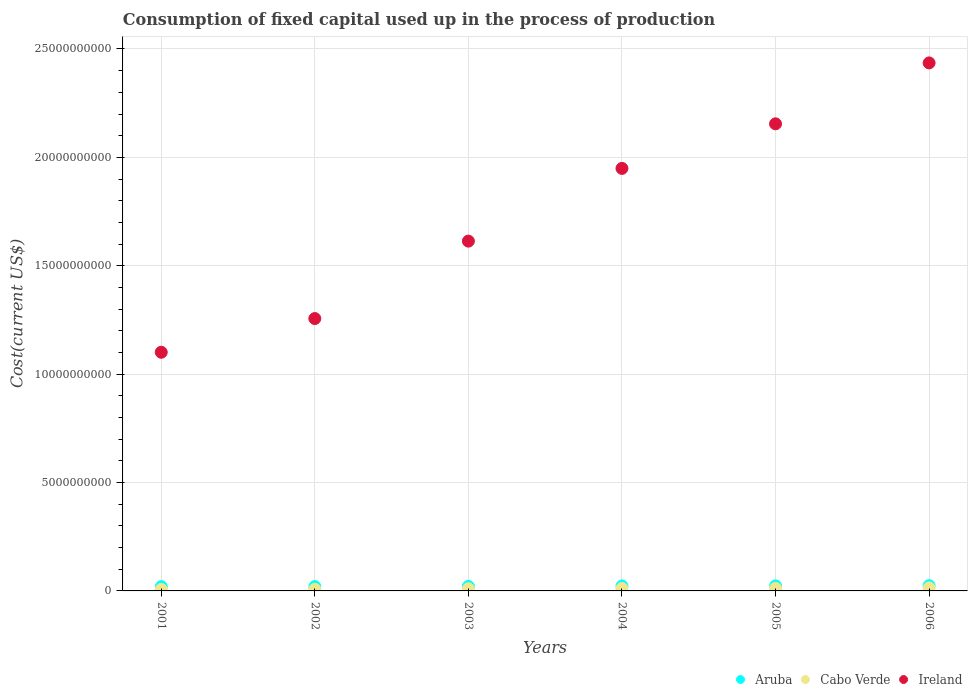What is the amount consumed in the process of production in Cabo Verde in 2005?
Your response must be concise. 1.20e+08. Across all years, what is the maximum amount consumed in the process of production in Cabo Verde?
Your answer should be very brief. 1.40e+08. Across all years, what is the minimum amount consumed in the process of production in Cabo Verde?
Give a very brief answer. 6.93e+07. In which year was the amount consumed in the process of production in Cabo Verde maximum?
Your response must be concise. 2006. What is the total amount consumed in the process of production in Cabo Verde in the graph?
Provide a succinct answer. 6.21e+08. What is the difference between the amount consumed in the process of production in Ireland in 2001 and that in 2006?
Ensure brevity in your answer.  -1.33e+1. What is the difference between the amount consumed in the process of production in Cabo Verde in 2004 and the amount consumed in the process of production in Aruba in 2003?
Your response must be concise. -9.54e+07. What is the average amount consumed in the process of production in Ireland per year?
Offer a very short reply. 1.75e+1. In the year 2002, what is the difference between the amount consumed in the process of production in Aruba and amount consumed in the process of production in Ireland?
Ensure brevity in your answer.  -1.24e+1. In how many years, is the amount consumed in the process of production in Cabo Verde greater than 17000000000 US$?
Ensure brevity in your answer.  0. What is the ratio of the amount consumed in the process of production in Cabo Verde in 2001 to that in 2002?
Your answer should be very brief. 0.9. Is the difference between the amount consumed in the process of production in Aruba in 2002 and 2005 greater than the difference between the amount consumed in the process of production in Ireland in 2002 and 2005?
Provide a short and direct response. Yes. What is the difference between the highest and the second highest amount consumed in the process of production in Ireland?
Give a very brief answer. 2.81e+09. What is the difference between the highest and the lowest amount consumed in the process of production in Aruba?
Provide a succinct answer. 4.61e+07. Is the sum of the amount consumed in the process of production in Cabo Verde in 2005 and 2006 greater than the maximum amount consumed in the process of production in Ireland across all years?
Make the answer very short. No. Is it the case that in every year, the sum of the amount consumed in the process of production in Cabo Verde and amount consumed in the process of production in Aruba  is greater than the amount consumed in the process of production in Ireland?
Your response must be concise. No. Does the amount consumed in the process of production in Cabo Verde monotonically increase over the years?
Provide a short and direct response. Yes. Is the amount consumed in the process of production in Ireland strictly less than the amount consumed in the process of production in Aruba over the years?
Your response must be concise. No. What is the difference between two consecutive major ticks on the Y-axis?
Ensure brevity in your answer.  5.00e+09. Are the values on the major ticks of Y-axis written in scientific E-notation?
Provide a short and direct response. No. Does the graph contain any zero values?
Provide a short and direct response. No. Does the graph contain grids?
Give a very brief answer. Yes. How many legend labels are there?
Give a very brief answer. 3. How are the legend labels stacked?
Keep it short and to the point. Horizontal. What is the title of the graph?
Your answer should be very brief. Consumption of fixed capital used up in the process of production. What is the label or title of the Y-axis?
Provide a succinct answer. Cost(current US$). What is the Cost(current US$) of Aruba in 2001?
Your answer should be compact. 1.98e+08. What is the Cost(current US$) of Cabo Verde in 2001?
Offer a terse response. 6.93e+07. What is the Cost(current US$) of Ireland in 2001?
Give a very brief answer. 1.10e+1. What is the Cost(current US$) in Aruba in 2002?
Make the answer very short. 2.00e+08. What is the Cost(current US$) of Cabo Verde in 2002?
Offer a very short reply. 7.71e+07. What is the Cost(current US$) in Ireland in 2002?
Give a very brief answer. 1.26e+1. What is the Cost(current US$) in Aruba in 2003?
Ensure brevity in your answer.  2.09e+08. What is the Cost(current US$) in Cabo Verde in 2003?
Offer a very short reply. 1.00e+08. What is the Cost(current US$) in Ireland in 2003?
Your answer should be compact. 1.61e+1. What is the Cost(current US$) of Aruba in 2004?
Your answer should be compact. 2.29e+08. What is the Cost(current US$) in Cabo Verde in 2004?
Offer a terse response. 1.13e+08. What is the Cost(current US$) of Ireland in 2004?
Ensure brevity in your answer.  1.95e+1. What is the Cost(current US$) in Aruba in 2005?
Provide a succinct answer. 2.33e+08. What is the Cost(current US$) of Cabo Verde in 2005?
Make the answer very short. 1.20e+08. What is the Cost(current US$) in Ireland in 2005?
Give a very brief answer. 2.15e+1. What is the Cost(current US$) in Aruba in 2006?
Make the answer very short. 2.44e+08. What is the Cost(current US$) of Cabo Verde in 2006?
Offer a very short reply. 1.40e+08. What is the Cost(current US$) of Ireland in 2006?
Offer a terse response. 2.44e+1. Across all years, what is the maximum Cost(current US$) of Aruba?
Offer a very short reply. 2.44e+08. Across all years, what is the maximum Cost(current US$) in Cabo Verde?
Give a very brief answer. 1.40e+08. Across all years, what is the maximum Cost(current US$) of Ireland?
Offer a terse response. 2.44e+1. Across all years, what is the minimum Cost(current US$) of Aruba?
Your answer should be compact. 1.98e+08. Across all years, what is the minimum Cost(current US$) of Cabo Verde?
Your answer should be compact. 6.93e+07. Across all years, what is the minimum Cost(current US$) in Ireland?
Provide a succinct answer. 1.10e+1. What is the total Cost(current US$) of Aruba in the graph?
Your response must be concise. 1.31e+09. What is the total Cost(current US$) in Cabo Verde in the graph?
Your answer should be very brief. 6.21e+08. What is the total Cost(current US$) of Ireland in the graph?
Give a very brief answer. 1.05e+11. What is the difference between the Cost(current US$) in Aruba in 2001 and that in 2002?
Your answer should be very brief. -2.55e+06. What is the difference between the Cost(current US$) of Cabo Verde in 2001 and that in 2002?
Give a very brief answer. -7.80e+06. What is the difference between the Cost(current US$) of Ireland in 2001 and that in 2002?
Your answer should be compact. -1.55e+09. What is the difference between the Cost(current US$) of Aruba in 2001 and that in 2003?
Offer a terse response. -1.09e+07. What is the difference between the Cost(current US$) in Cabo Verde in 2001 and that in 2003?
Your response must be concise. -3.11e+07. What is the difference between the Cost(current US$) of Ireland in 2001 and that in 2003?
Your answer should be very brief. -5.13e+09. What is the difference between the Cost(current US$) in Aruba in 2001 and that in 2004?
Offer a very short reply. -3.11e+07. What is the difference between the Cost(current US$) of Cabo Verde in 2001 and that in 2004?
Provide a short and direct response. -4.38e+07. What is the difference between the Cost(current US$) of Ireland in 2001 and that in 2004?
Your response must be concise. -8.48e+09. What is the difference between the Cost(current US$) of Aruba in 2001 and that in 2005?
Keep it short and to the point. -3.52e+07. What is the difference between the Cost(current US$) of Cabo Verde in 2001 and that in 2005?
Make the answer very short. -5.11e+07. What is the difference between the Cost(current US$) in Ireland in 2001 and that in 2005?
Offer a terse response. -1.05e+1. What is the difference between the Cost(current US$) of Aruba in 2001 and that in 2006?
Keep it short and to the point. -4.61e+07. What is the difference between the Cost(current US$) in Cabo Verde in 2001 and that in 2006?
Provide a short and direct response. -7.11e+07. What is the difference between the Cost(current US$) in Ireland in 2001 and that in 2006?
Keep it short and to the point. -1.33e+1. What is the difference between the Cost(current US$) in Aruba in 2002 and that in 2003?
Your answer should be very brief. -8.33e+06. What is the difference between the Cost(current US$) in Cabo Verde in 2002 and that in 2003?
Your response must be concise. -2.33e+07. What is the difference between the Cost(current US$) of Ireland in 2002 and that in 2003?
Your answer should be compact. -3.57e+09. What is the difference between the Cost(current US$) in Aruba in 2002 and that in 2004?
Keep it short and to the point. -2.85e+07. What is the difference between the Cost(current US$) of Cabo Verde in 2002 and that in 2004?
Provide a succinct answer. -3.60e+07. What is the difference between the Cost(current US$) in Ireland in 2002 and that in 2004?
Your answer should be very brief. -6.93e+09. What is the difference between the Cost(current US$) in Aruba in 2002 and that in 2005?
Offer a terse response. -3.26e+07. What is the difference between the Cost(current US$) of Cabo Verde in 2002 and that in 2005?
Offer a very short reply. -4.33e+07. What is the difference between the Cost(current US$) in Ireland in 2002 and that in 2005?
Provide a short and direct response. -8.98e+09. What is the difference between the Cost(current US$) of Aruba in 2002 and that in 2006?
Offer a very short reply. -4.35e+07. What is the difference between the Cost(current US$) in Cabo Verde in 2002 and that in 2006?
Ensure brevity in your answer.  -6.33e+07. What is the difference between the Cost(current US$) of Ireland in 2002 and that in 2006?
Your answer should be very brief. -1.18e+1. What is the difference between the Cost(current US$) of Aruba in 2003 and that in 2004?
Your response must be concise. -2.02e+07. What is the difference between the Cost(current US$) in Cabo Verde in 2003 and that in 2004?
Provide a succinct answer. -1.27e+07. What is the difference between the Cost(current US$) of Ireland in 2003 and that in 2004?
Your answer should be very brief. -3.36e+09. What is the difference between the Cost(current US$) of Aruba in 2003 and that in 2005?
Your answer should be very brief. -2.43e+07. What is the difference between the Cost(current US$) in Cabo Verde in 2003 and that in 2005?
Your answer should be very brief. -2.00e+07. What is the difference between the Cost(current US$) of Ireland in 2003 and that in 2005?
Offer a terse response. -5.41e+09. What is the difference between the Cost(current US$) in Aruba in 2003 and that in 2006?
Your response must be concise. -3.52e+07. What is the difference between the Cost(current US$) of Cabo Verde in 2003 and that in 2006?
Your response must be concise. -4.00e+07. What is the difference between the Cost(current US$) in Ireland in 2003 and that in 2006?
Offer a very short reply. -8.22e+09. What is the difference between the Cost(current US$) of Aruba in 2004 and that in 2005?
Offer a very short reply. -4.15e+06. What is the difference between the Cost(current US$) in Cabo Verde in 2004 and that in 2005?
Provide a succinct answer. -7.27e+06. What is the difference between the Cost(current US$) in Ireland in 2004 and that in 2005?
Your answer should be very brief. -2.06e+09. What is the difference between the Cost(current US$) in Aruba in 2004 and that in 2006?
Make the answer very short. -1.50e+07. What is the difference between the Cost(current US$) in Cabo Verde in 2004 and that in 2006?
Keep it short and to the point. -2.73e+07. What is the difference between the Cost(current US$) in Ireland in 2004 and that in 2006?
Keep it short and to the point. -4.87e+09. What is the difference between the Cost(current US$) in Aruba in 2005 and that in 2006?
Offer a terse response. -1.09e+07. What is the difference between the Cost(current US$) of Cabo Verde in 2005 and that in 2006?
Give a very brief answer. -2.00e+07. What is the difference between the Cost(current US$) of Ireland in 2005 and that in 2006?
Offer a very short reply. -2.81e+09. What is the difference between the Cost(current US$) in Aruba in 2001 and the Cost(current US$) in Cabo Verde in 2002?
Provide a succinct answer. 1.21e+08. What is the difference between the Cost(current US$) in Aruba in 2001 and the Cost(current US$) in Ireland in 2002?
Your answer should be compact. -1.24e+1. What is the difference between the Cost(current US$) in Cabo Verde in 2001 and the Cost(current US$) in Ireland in 2002?
Keep it short and to the point. -1.25e+1. What is the difference between the Cost(current US$) of Aruba in 2001 and the Cost(current US$) of Cabo Verde in 2003?
Make the answer very short. 9.73e+07. What is the difference between the Cost(current US$) of Aruba in 2001 and the Cost(current US$) of Ireland in 2003?
Ensure brevity in your answer.  -1.59e+1. What is the difference between the Cost(current US$) in Cabo Verde in 2001 and the Cost(current US$) in Ireland in 2003?
Provide a succinct answer. -1.61e+1. What is the difference between the Cost(current US$) in Aruba in 2001 and the Cost(current US$) in Cabo Verde in 2004?
Make the answer very short. 8.46e+07. What is the difference between the Cost(current US$) in Aruba in 2001 and the Cost(current US$) in Ireland in 2004?
Your response must be concise. -1.93e+1. What is the difference between the Cost(current US$) in Cabo Verde in 2001 and the Cost(current US$) in Ireland in 2004?
Keep it short and to the point. -1.94e+1. What is the difference between the Cost(current US$) in Aruba in 2001 and the Cost(current US$) in Cabo Verde in 2005?
Offer a very short reply. 7.73e+07. What is the difference between the Cost(current US$) in Aruba in 2001 and the Cost(current US$) in Ireland in 2005?
Offer a terse response. -2.13e+1. What is the difference between the Cost(current US$) in Cabo Verde in 2001 and the Cost(current US$) in Ireland in 2005?
Ensure brevity in your answer.  -2.15e+1. What is the difference between the Cost(current US$) of Aruba in 2001 and the Cost(current US$) of Cabo Verde in 2006?
Make the answer very short. 5.73e+07. What is the difference between the Cost(current US$) of Aruba in 2001 and the Cost(current US$) of Ireland in 2006?
Keep it short and to the point. -2.42e+1. What is the difference between the Cost(current US$) of Cabo Verde in 2001 and the Cost(current US$) of Ireland in 2006?
Ensure brevity in your answer.  -2.43e+1. What is the difference between the Cost(current US$) of Aruba in 2002 and the Cost(current US$) of Cabo Verde in 2003?
Your answer should be very brief. 9.98e+07. What is the difference between the Cost(current US$) of Aruba in 2002 and the Cost(current US$) of Ireland in 2003?
Provide a succinct answer. -1.59e+1. What is the difference between the Cost(current US$) of Cabo Verde in 2002 and the Cost(current US$) of Ireland in 2003?
Your answer should be compact. -1.61e+1. What is the difference between the Cost(current US$) in Aruba in 2002 and the Cost(current US$) in Cabo Verde in 2004?
Your response must be concise. 8.71e+07. What is the difference between the Cost(current US$) of Aruba in 2002 and the Cost(current US$) of Ireland in 2004?
Your response must be concise. -1.93e+1. What is the difference between the Cost(current US$) of Cabo Verde in 2002 and the Cost(current US$) of Ireland in 2004?
Give a very brief answer. -1.94e+1. What is the difference between the Cost(current US$) of Aruba in 2002 and the Cost(current US$) of Cabo Verde in 2005?
Provide a succinct answer. 7.98e+07. What is the difference between the Cost(current US$) in Aruba in 2002 and the Cost(current US$) in Ireland in 2005?
Offer a very short reply. -2.13e+1. What is the difference between the Cost(current US$) of Cabo Verde in 2002 and the Cost(current US$) of Ireland in 2005?
Your answer should be compact. -2.15e+1. What is the difference between the Cost(current US$) in Aruba in 2002 and the Cost(current US$) in Cabo Verde in 2006?
Give a very brief answer. 5.98e+07. What is the difference between the Cost(current US$) of Aruba in 2002 and the Cost(current US$) of Ireland in 2006?
Provide a succinct answer. -2.42e+1. What is the difference between the Cost(current US$) in Cabo Verde in 2002 and the Cost(current US$) in Ireland in 2006?
Offer a very short reply. -2.43e+1. What is the difference between the Cost(current US$) of Aruba in 2003 and the Cost(current US$) of Cabo Verde in 2004?
Give a very brief answer. 9.54e+07. What is the difference between the Cost(current US$) of Aruba in 2003 and the Cost(current US$) of Ireland in 2004?
Offer a very short reply. -1.93e+1. What is the difference between the Cost(current US$) in Cabo Verde in 2003 and the Cost(current US$) in Ireland in 2004?
Keep it short and to the point. -1.94e+1. What is the difference between the Cost(current US$) in Aruba in 2003 and the Cost(current US$) in Cabo Verde in 2005?
Provide a succinct answer. 8.82e+07. What is the difference between the Cost(current US$) of Aruba in 2003 and the Cost(current US$) of Ireland in 2005?
Your answer should be very brief. -2.13e+1. What is the difference between the Cost(current US$) of Cabo Verde in 2003 and the Cost(current US$) of Ireland in 2005?
Your response must be concise. -2.14e+1. What is the difference between the Cost(current US$) in Aruba in 2003 and the Cost(current US$) in Cabo Verde in 2006?
Your response must be concise. 6.82e+07. What is the difference between the Cost(current US$) of Aruba in 2003 and the Cost(current US$) of Ireland in 2006?
Offer a very short reply. -2.41e+1. What is the difference between the Cost(current US$) in Cabo Verde in 2003 and the Cost(current US$) in Ireland in 2006?
Give a very brief answer. -2.43e+1. What is the difference between the Cost(current US$) of Aruba in 2004 and the Cost(current US$) of Cabo Verde in 2005?
Provide a succinct answer. 1.08e+08. What is the difference between the Cost(current US$) of Aruba in 2004 and the Cost(current US$) of Ireland in 2005?
Give a very brief answer. -2.13e+1. What is the difference between the Cost(current US$) of Cabo Verde in 2004 and the Cost(current US$) of Ireland in 2005?
Provide a short and direct response. -2.14e+1. What is the difference between the Cost(current US$) in Aruba in 2004 and the Cost(current US$) in Cabo Verde in 2006?
Keep it short and to the point. 8.83e+07. What is the difference between the Cost(current US$) in Aruba in 2004 and the Cost(current US$) in Ireland in 2006?
Your answer should be very brief. -2.41e+1. What is the difference between the Cost(current US$) in Cabo Verde in 2004 and the Cost(current US$) in Ireland in 2006?
Your response must be concise. -2.42e+1. What is the difference between the Cost(current US$) in Aruba in 2005 and the Cost(current US$) in Cabo Verde in 2006?
Your response must be concise. 9.25e+07. What is the difference between the Cost(current US$) of Aruba in 2005 and the Cost(current US$) of Ireland in 2006?
Keep it short and to the point. -2.41e+1. What is the difference between the Cost(current US$) of Cabo Verde in 2005 and the Cost(current US$) of Ireland in 2006?
Give a very brief answer. -2.42e+1. What is the average Cost(current US$) in Aruba per year?
Provide a succinct answer. 2.19e+08. What is the average Cost(current US$) in Cabo Verde per year?
Your answer should be very brief. 1.03e+08. What is the average Cost(current US$) of Ireland per year?
Your answer should be compact. 1.75e+1. In the year 2001, what is the difference between the Cost(current US$) in Aruba and Cost(current US$) in Cabo Verde?
Provide a short and direct response. 1.28e+08. In the year 2001, what is the difference between the Cost(current US$) in Aruba and Cost(current US$) in Ireland?
Your response must be concise. -1.08e+1. In the year 2001, what is the difference between the Cost(current US$) of Cabo Verde and Cost(current US$) of Ireland?
Keep it short and to the point. -1.09e+1. In the year 2002, what is the difference between the Cost(current US$) of Aruba and Cost(current US$) of Cabo Verde?
Ensure brevity in your answer.  1.23e+08. In the year 2002, what is the difference between the Cost(current US$) of Aruba and Cost(current US$) of Ireland?
Offer a terse response. -1.24e+1. In the year 2002, what is the difference between the Cost(current US$) of Cabo Verde and Cost(current US$) of Ireland?
Offer a very short reply. -1.25e+1. In the year 2003, what is the difference between the Cost(current US$) of Aruba and Cost(current US$) of Cabo Verde?
Keep it short and to the point. 1.08e+08. In the year 2003, what is the difference between the Cost(current US$) in Aruba and Cost(current US$) in Ireland?
Ensure brevity in your answer.  -1.59e+1. In the year 2003, what is the difference between the Cost(current US$) in Cabo Verde and Cost(current US$) in Ireland?
Provide a short and direct response. -1.60e+1. In the year 2004, what is the difference between the Cost(current US$) of Aruba and Cost(current US$) of Cabo Verde?
Your response must be concise. 1.16e+08. In the year 2004, what is the difference between the Cost(current US$) in Aruba and Cost(current US$) in Ireland?
Your response must be concise. -1.93e+1. In the year 2004, what is the difference between the Cost(current US$) of Cabo Verde and Cost(current US$) of Ireland?
Offer a very short reply. -1.94e+1. In the year 2005, what is the difference between the Cost(current US$) in Aruba and Cost(current US$) in Cabo Verde?
Your response must be concise. 1.12e+08. In the year 2005, what is the difference between the Cost(current US$) in Aruba and Cost(current US$) in Ireland?
Give a very brief answer. -2.13e+1. In the year 2005, what is the difference between the Cost(current US$) of Cabo Verde and Cost(current US$) of Ireland?
Offer a very short reply. -2.14e+1. In the year 2006, what is the difference between the Cost(current US$) in Aruba and Cost(current US$) in Cabo Verde?
Offer a very short reply. 1.03e+08. In the year 2006, what is the difference between the Cost(current US$) in Aruba and Cost(current US$) in Ireland?
Your response must be concise. -2.41e+1. In the year 2006, what is the difference between the Cost(current US$) in Cabo Verde and Cost(current US$) in Ireland?
Ensure brevity in your answer.  -2.42e+1. What is the ratio of the Cost(current US$) of Aruba in 2001 to that in 2002?
Provide a short and direct response. 0.99. What is the ratio of the Cost(current US$) of Cabo Verde in 2001 to that in 2002?
Make the answer very short. 0.9. What is the ratio of the Cost(current US$) in Ireland in 2001 to that in 2002?
Your answer should be very brief. 0.88. What is the ratio of the Cost(current US$) in Aruba in 2001 to that in 2003?
Make the answer very short. 0.95. What is the ratio of the Cost(current US$) in Cabo Verde in 2001 to that in 2003?
Your answer should be compact. 0.69. What is the ratio of the Cost(current US$) in Ireland in 2001 to that in 2003?
Your answer should be compact. 0.68. What is the ratio of the Cost(current US$) in Aruba in 2001 to that in 2004?
Offer a terse response. 0.86. What is the ratio of the Cost(current US$) of Cabo Verde in 2001 to that in 2004?
Make the answer very short. 0.61. What is the ratio of the Cost(current US$) in Ireland in 2001 to that in 2004?
Keep it short and to the point. 0.56. What is the ratio of the Cost(current US$) in Aruba in 2001 to that in 2005?
Your response must be concise. 0.85. What is the ratio of the Cost(current US$) in Cabo Verde in 2001 to that in 2005?
Your answer should be very brief. 0.58. What is the ratio of the Cost(current US$) in Ireland in 2001 to that in 2005?
Ensure brevity in your answer.  0.51. What is the ratio of the Cost(current US$) in Aruba in 2001 to that in 2006?
Your answer should be compact. 0.81. What is the ratio of the Cost(current US$) in Cabo Verde in 2001 to that in 2006?
Make the answer very short. 0.49. What is the ratio of the Cost(current US$) in Ireland in 2001 to that in 2006?
Your answer should be compact. 0.45. What is the ratio of the Cost(current US$) of Aruba in 2002 to that in 2003?
Your response must be concise. 0.96. What is the ratio of the Cost(current US$) of Cabo Verde in 2002 to that in 2003?
Ensure brevity in your answer.  0.77. What is the ratio of the Cost(current US$) in Ireland in 2002 to that in 2003?
Your answer should be compact. 0.78. What is the ratio of the Cost(current US$) in Aruba in 2002 to that in 2004?
Make the answer very short. 0.88. What is the ratio of the Cost(current US$) in Cabo Verde in 2002 to that in 2004?
Keep it short and to the point. 0.68. What is the ratio of the Cost(current US$) in Ireland in 2002 to that in 2004?
Your answer should be compact. 0.64. What is the ratio of the Cost(current US$) in Aruba in 2002 to that in 2005?
Provide a short and direct response. 0.86. What is the ratio of the Cost(current US$) in Cabo Verde in 2002 to that in 2005?
Make the answer very short. 0.64. What is the ratio of the Cost(current US$) in Ireland in 2002 to that in 2005?
Keep it short and to the point. 0.58. What is the ratio of the Cost(current US$) in Aruba in 2002 to that in 2006?
Make the answer very short. 0.82. What is the ratio of the Cost(current US$) of Cabo Verde in 2002 to that in 2006?
Provide a short and direct response. 0.55. What is the ratio of the Cost(current US$) in Ireland in 2002 to that in 2006?
Make the answer very short. 0.52. What is the ratio of the Cost(current US$) in Aruba in 2003 to that in 2004?
Give a very brief answer. 0.91. What is the ratio of the Cost(current US$) of Cabo Verde in 2003 to that in 2004?
Ensure brevity in your answer.  0.89. What is the ratio of the Cost(current US$) of Ireland in 2003 to that in 2004?
Ensure brevity in your answer.  0.83. What is the ratio of the Cost(current US$) of Aruba in 2003 to that in 2005?
Keep it short and to the point. 0.9. What is the ratio of the Cost(current US$) in Cabo Verde in 2003 to that in 2005?
Keep it short and to the point. 0.83. What is the ratio of the Cost(current US$) in Ireland in 2003 to that in 2005?
Keep it short and to the point. 0.75. What is the ratio of the Cost(current US$) of Aruba in 2003 to that in 2006?
Make the answer very short. 0.86. What is the ratio of the Cost(current US$) of Cabo Verde in 2003 to that in 2006?
Provide a succinct answer. 0.72. What is the ratio of the Cost(current US$) of Ireland in 2003 to that in 2006?
Provide a short and direct response. 0.66. What is the ratio of the Cost(current US$) in Aruba in 2004 to that in 2005?
Offer a very short reply. 0.98. What is the ratio of the Cost(current US$) in Cabo Verde in 2004 to that in 2005?
Offer a very short reply. 0.94. What is the ratio of the Cost(current US$) in Ireland in 2004 to that in 2005?
Keep it short and to the point. 0.9. What is the ratio of the Cost(current US$) in Aruba in 2004 to that in 2006?
Give a very brief answer. 0.94. What is the ratio of the Cost(current US$) in Cabo Verde in 2004 to that in 2006?
Ensure brevity in your answer.  0.81. What is the ratio of the Cost(current US$) in Ireland in 2004 to that in 2006?
Ensure brevity in your answer.  0.8. What is the ratio of the Cost(current US$) of Aruba in 2005 to that in 2006?
Provide a succinct answer. 0.96. What is the ratio of the Cost(current US$) in Cabo Verde in 2005 to that in 2006?
Make the answer very short. 0.86. What is the ratio of the Cost(current US$) of Ireland in 2005 to that in 2006?
Give a very brief answer. 0.88. What is the difference between the highest and the second highest Cost(current US$) in Aruba?
Your response must be concise. 1.09e+07. What is the difference between the highest and the second highest Cost(current US$) of Cabo Verde?
Ensure brevity in your answer.  2.00e+07. What is the difference between the highest and the second highest Cost(current US$) in Ireland?
Keep it short and to the point. 2.81e+09. What is the difference between the highest and the lowest Cost(current US$) of Aruba?
Ensure brevity in your answer.  4.61e+07. What is the difference between the highest and the lowest Cost(current US$) in Cabo Verde?
Offer a very short reply. 7.11e+07. What is the difference between the highest and the lowest Cost(current US$) of Ireland?
Offer a very short reply. 1.33e+1. 